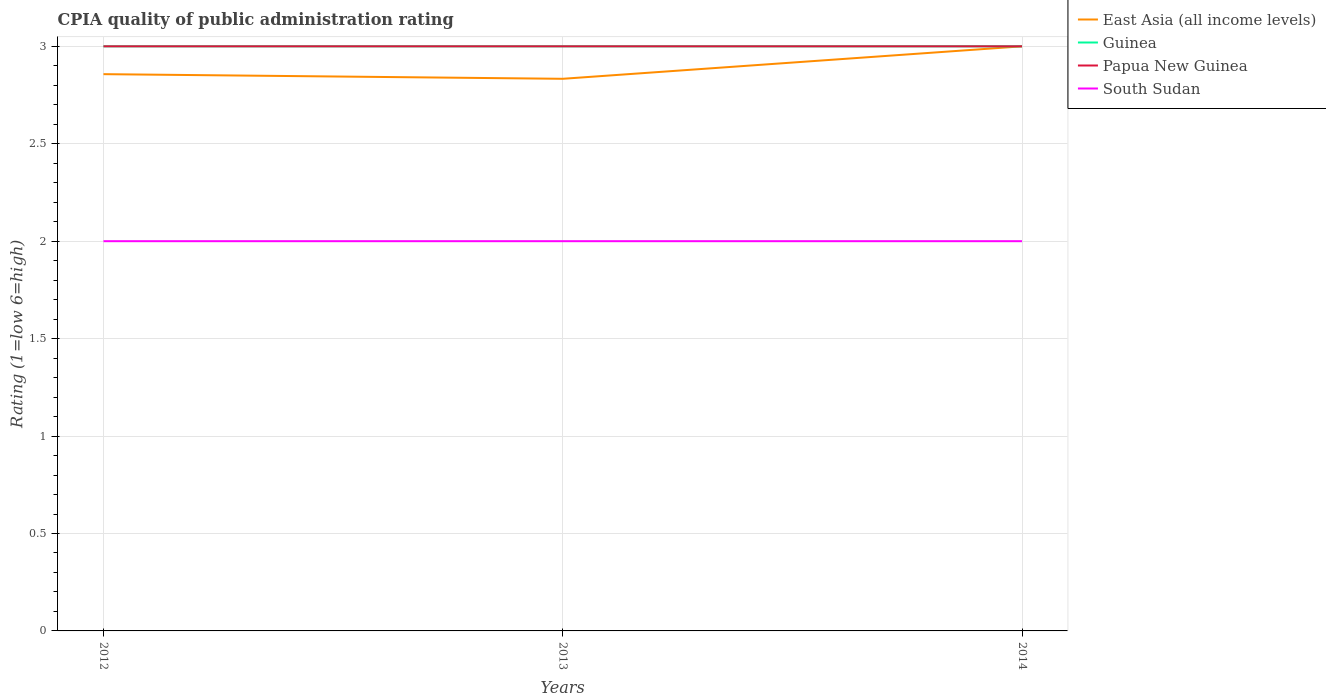Does the line corresponding to Papua New Guinea intersect with the line corresponding to Guinea?
Your answer should be compact. Yes. Across all years, what is the maximum CPIA rating in Guinea?
Keep it short and to the point. 3. In which year was the CPIA rating in South Sudan maximum?
Offer a very short reply. 2012. Is the CPIA rating in South Sudan strictly greater than the CPIA rating in Papua New Guinea over the years?
Offer a terse response. Yes. Are the values on the major ticks of Y-axis written in scientific E-notation?
Your response must be concise. No. Does the graph contain any zero values?
Provide a succinct answer. No. Where does the legend appear in the graph?
Keep it short and to the point. Top right. How many legend labels are there?
Your answer should be compact. 4. How are the legend labels stacked?
Offer a very short reply. Vertical. What is the title of the graph?
Offer a very short reply. CPIA quality of public administration rating. What is the label or title of the X-axis?
Give a very brief answer. Years. What is the label or title of the Y-axis?
Provide a succinct answer. Rating (1=low 6=high). What is the Rating (1=low 6=high) of East Asia (all income levels) in 2012?
Give a very brief answer. 2.86. What is the Rating (1=low 6=high) in East Asia (all income levels) in 2013?
Ensure brevity in your answer.  2.83. What is the Rating (1=low 6=high) of Papua New Guinea in 2013?
Ensure brevity in your answer.  3. What is the Rating (1=low 6=high) of South Sudan in 2013?
Give a very brief answer. 2. What is the Rating (1=low 6=high) in East Asia (all income levels) in 2014?
Make the answer very short. 3. What is the Rating (1=low 6=high) in Guinea in 2014?
Your answer should be compact. 3. What is the Rating (1=low 6=high) of Papua New Guinea in 2014?
Make the answer very short. 3. Across all years, what is the maximum Rating (1=low 6=high) of Guinea?
Provide a succinct answer. 3. Across all years, what is the minimum Rating (1=low 6=high) in East Asia (all income levels)?
Give a very brief answer. 2.83. Across all years, what is the minimum Rating (1=low 6=high) of Guinea?
Ensure brevity in your answer.  3. Across all years, what is the minimum Rating (1=low 6=high) in Papua New Guinea?
Ensure brevity in your answer.  3. Across all years, what is the minimum Rating (1=low 6=high) in South Sudan?
Offer a terse response. 2. What is the total Rating (1=low 6=high) in East Asia (all income levels) in the graph?
Offer a terse response. 8.69. What is the total Rating (1=low 6=high) of Papua New Guinea in the graph?
Offer a terse response. 9. What is the difference between the Rating (1=low 6=high) of East Asia (all income levels) in 2012 and that in 2013?
Your response must be concise. 0.02. What is the difference between the Rating (1=low 6=high) of Guinea in 2012 and that in 2013?
Offer a terse response. 0. What is the difference between the Rating (1=low 6=high) in Papua New Guinea in 2012 and that in 2013?
Make the answer very short. 0. What is the difference between the Rating (1=low 6=high) in South Sudan in 2012 and that in 2013?
Your answer should be very brief. 0. What is the difference between the Rating (1=low 6=high) in East Asia (all income levels) in 2012 and that in 2014?
Provide a short and direct response. -0.14. What is the difference between the Rating (1=low 6=high) of Guinea in 2012 and that in 2014?
Provide a succinct answer. 0. What is the difference between the Rating (1=low 6=high) of South Sudan in 2012 and that in 2014?
Provide a succinct answer. 0. What is the difference between the Rating (1=low 6=high) of East Asia (all income levels) in 2013 and that in 2014?
Provide a succinct answer. -0.17. What is the difference between the Rating (1=low 6=high) of East Asia (all income levels) in 2012 and the Rating (1=low 6=high) of Guinea in 2013?
Provide a succinct answer. -0.14. What is the difference between the Rating (1=low 6=high) in East Asia (all income levels) in 2012 and the Rating (1=low 6=high) in Papua New Guinea in 2013?
Offer a very short reply. -0.14. What is the difference between the Rating (1=low 6=high) in East Asia (all income levels) in 2012 and the Rating (1=low 6=high) in South Sudan in 2013?
Provide a short and direct response. 0.86. What is the difference between the Rating (1=low 6=high) of Guinea in 2012 and the Rating (1=low 6=high) of Papua New Guinea in 2013?
Make the answer very short. 0. What is the difference between the Rating (1=low 6=high) in Guinea in 2012 and the Rating (1=low 6=high) in South Sudan in 2013?
Provide a short and direct response. 1. What is the difference between the Rating (1=low 6=high) in East Asia (all income levels) in 2012 and the Rating (1=low 6=high) in Guinea in 2014?
Your answer should be compact. -0.14. What is the difference between the Rating (1=low 6=high) of East Asia (all income levels) in 2012 and the Rating (1=low 6=high) of Papua New Guinea in 2014?
Your answer should be very brief. -0.14. What is the difference between the Rating (1=low 6=high) in East Asia (all income levels) in 2012 and the Rating (1=low 6=high) in South Sudan in 2014?
Make the answer very short. 0.86. What is the difference between the Rating (1=low 6=high) in Guinea in 2012 and the Rating (1=low 6=high) in Papua New Guinea in 2014?
Provide a succinct answer. 0. What is the difference between the Rating (1=low 6=high) of Guinea in 2012 and the Rating (1=low 6=high) of South Sudan in 2014?
Your response must be concise. 1. What is the difference between the Rating (1=low 6=high) of Guinea in 2013 and the Rating (1=low 6=high) of Papua New Guinea in 2014?
Offer a terse response. 0. What is the difference between the Rating (1=low 6=high) of Guinea in 2013 and the Rating (1=low 6=high) of South Sudan in 2014?
Give a very brief answer. 1. What is the average Rating (1=low 6=high) in East Asia (all income levels) per year?
Your response must be concise. 2.9. What is the average Rating (1=low 6=high) in Papua New Guinea per year?
Provide a short and direct response. 3. In the year 2012, what is the difference between the Rating (1=low 6=high) of East Asia (all income levels) and Rating (1=low 6=high) of Guinea?
Your answer should be very brief. -0.14. In the year 2012, what is the difference between the Rating (1=low 6=high) of East Asia (all income levels) and Rating (1=low 6=high) of Papua New Guinea?
Provide a short and direct response. -0.14. In the year 2013, what is the difference between the Rating (1=low 6=high) of East Asia (all income levels) and Rating (1=low 6=high) of Papua New Guinea?
Make the answer very short. -0.17. In the year 2013, what is the difference between the Rating (1=low 6=high) of Guinea and Rating (1=low 6=high) of South Sudan?
Offer a terse response. 1. In the year 2013, what is the difference between the Rating (1=low 6=high) in Papua New Guinea and Rating (1=low 6=high) in South Sudan?
Make the answer very short. 1. In the year 2014, what is the difference between the Rating (1=low 6=high) in East Asia (all income levels) and Rating (1=low 6=high) in Papua New Guinea?
Keep it short and to the point. 0. In the year 2014, what is the difference between the Rating (1=low 6=high) in Guinea and Rating (1=low 6=high) in South Sudan?
Offer a terse response. 1. In the year 2014, what is the difference between the Rating (1=low 6=high) of Papua New Guinea and Rating (1=low 6=high) of South Sudan?
Ensure brevity in your answer.  1. What is the ratio of the Rating (1=low 6=high) in East Asia (all income levels) in 2012 to that in 2013?
Your response must be concise. 1.01. What is the ratio of the Rating (1=low 6=high) of Guinea in 2012 to that in 2014?
Keep it short and to the point. 1. What is the ratio of the Rating (1=low 6=high) of East Asia (all income levels) in 2013 to that in 2014?
Give a very brief answer. 0.94. What is the ratio of the Rating (1=low 6=high) of Guinea in 2013 to that in 2014?
Your response must be concise. 1. What is the ratio of the Rating (1=low 6=high) in South Sudan in 2013 to that in 2014?
Give a very brief answer. 1. What is the difference between the highest and the second highest Rating (1=low 6=high) in East Asia (all income levels)?
Give a very brief answer. 0.14. What is the difference between the highest and the second highest Rating (1=low 6=high) in Guinea?
Offer a terse response. 0. What is the difference between the highest and the second highest Rating (1=low 6=high) in Papua New Guinea?
Keep it short and to the point. 0. What is the difference between the highest and the second highest Rating (1=low 6=high) of South Sudan?
Keep it short and to the point. 0. What is the difference between the highest and the lowest Rating (1=low 6=high) in Guinea?
Your response must be concise. 0. What is the difference between the highest and the lowest Rating (1=low 6=high) of Papua New Guinea?
Provide a succinct answer. 0. 